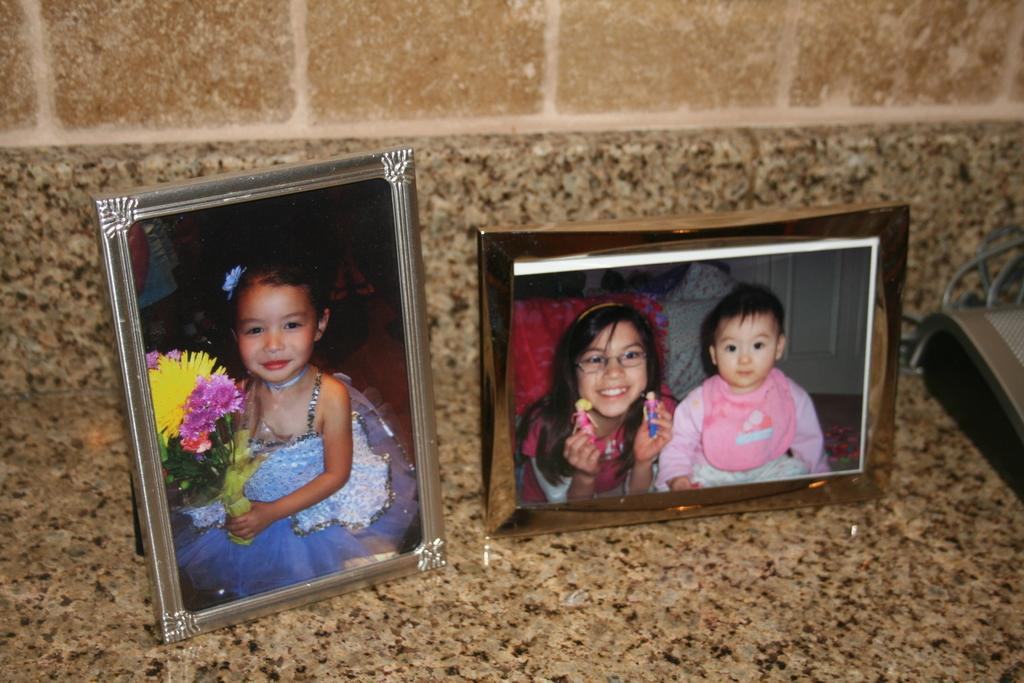How many photo frames are visible in the image? There are two photo frames in the image. Where are the photo frames located? The photo frames are on a desk or an object. What type of animal can be seen in the moon in the image? There is no moon or animal present in the image; it only features two photo frames on a desk or an object. 